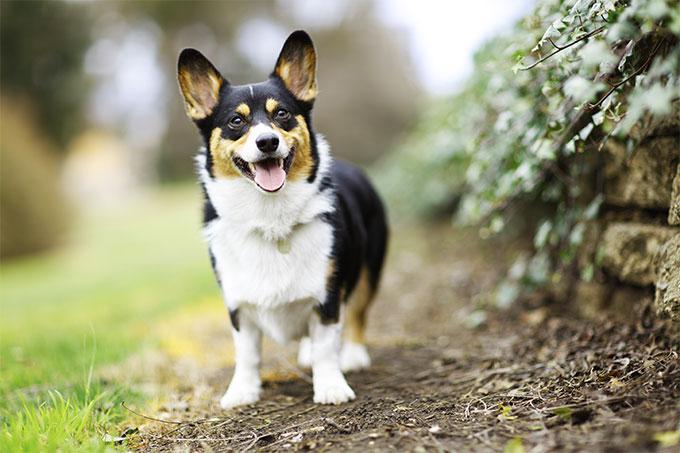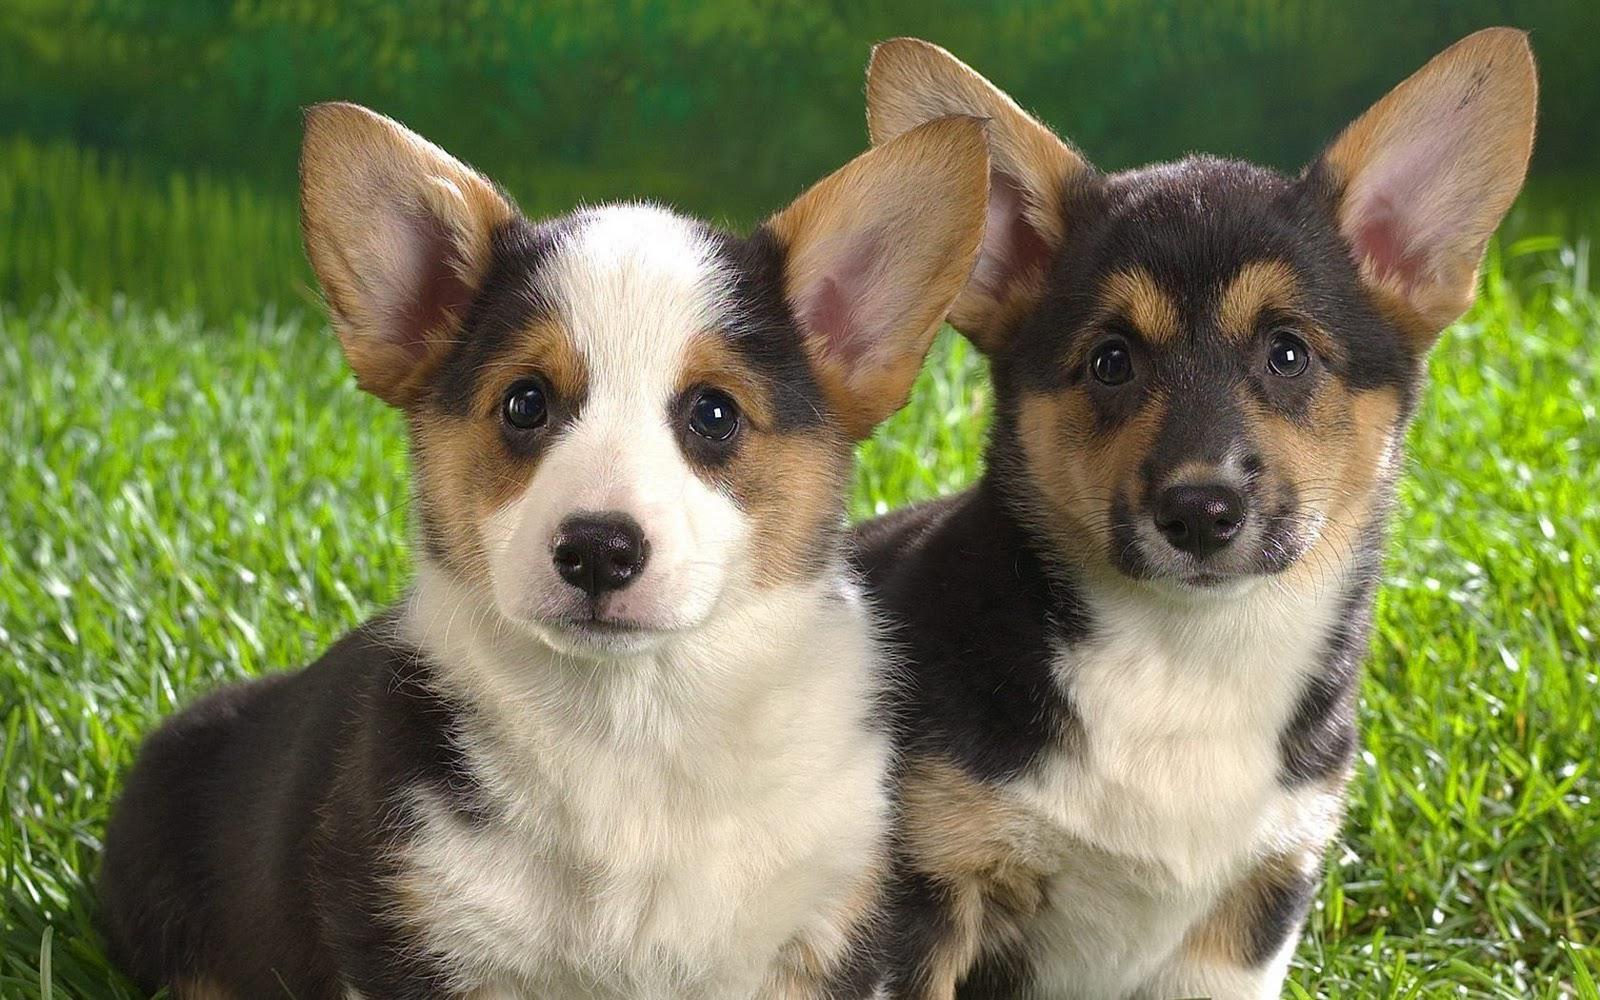The first image is the image on the left, the second image is the image on the right. For the images displayed, is the sentence "The right image includes twice the number of dogs as the left image." factually correct? Answer yes or no. Yes. The first image is the image on the left, the second image is the image on the right. Considering the images on both sides, is "Two corgies sit side by side in one image, while another corgi with its mouth open and tongue showing is alone in the other image." valid? Answer yes or no. Yes. 